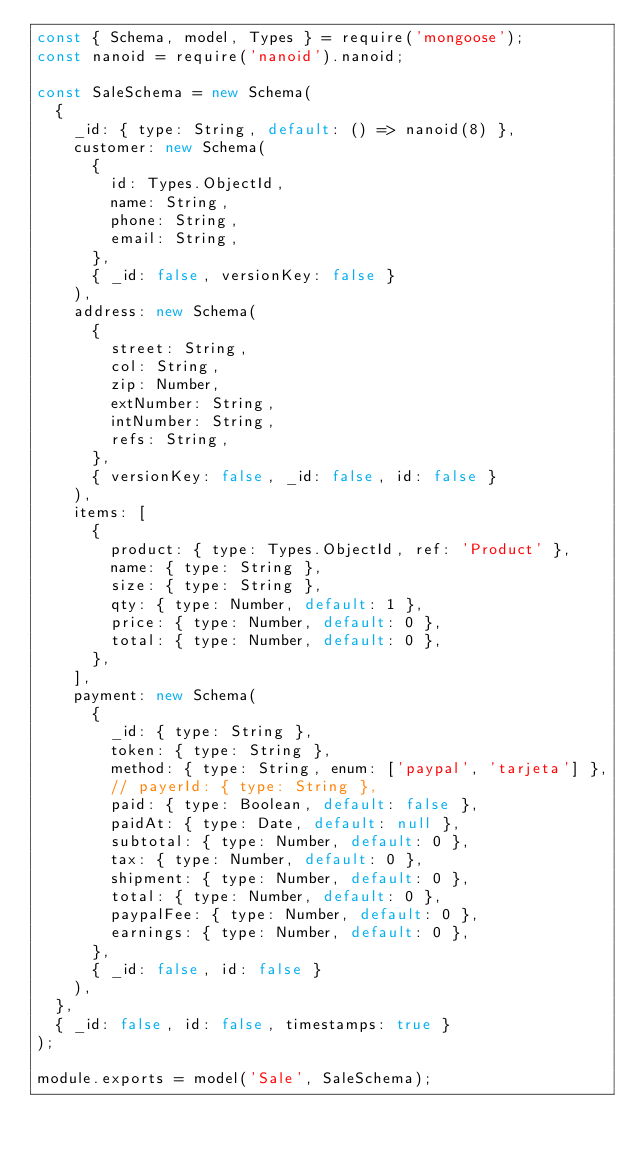<code> <loc_0><loc_0><loc_500><loc_500><_JavaScript_>const { Schema, model, Types } = require('mongoose');
const nanoid = require('nanoid').nanoid;

const SaleSchema = new Schema(
  {
    _id: { type: String, default: () => nanoid(8) },
    customer: new Schema(
      {
        id: Types.ObjectId,
        name: String,
        phone: String,
        email: String,
      },
      { _id: false, versionKey: false }
    ),
    address: new Schema(
      {
        street: String,
        col: String,
        zip: Number,
        extNumber: String,
        intNumber: String,
        refs: String,
      },
      { versionKey: false, _id: false, id: false }
    ),
    items: [
      {
        product: { type: Types.ObjectId, ref: 'Product' },
        name: { type: String },
        size: { type: String },
        qty: { type: Number, default: 1 },
        price: { type: Number, default: 0 },
        total: { type: Number, default: 0 },
      },
    ],
    payment: new Schema(
      {
        _id: { type: String },
        token: { type: String },
        method: { type: String, enum: ['paypal', 'tarjeta'] },
        // payerId: { type: String },
        paid: { type: Boolean, default: false },
        paidAt: { type: Date, default: null },
        subtotal: { type: Number, default: 0 },
        tax: { type: Number, default: 0 },
        shipment: { type: Number, default: 0 },
        total: { type: Number, default: 0 },
        paypalFee: { type: Number, default: 0 },
        earnings: { type: Number, default: 0 },
      },
      { _id: false, id: false }
    ),
  },
  { _id: false, id: false, timestamps: true }
);

module.exports = model('Sale', SaleSchema);
</code> 